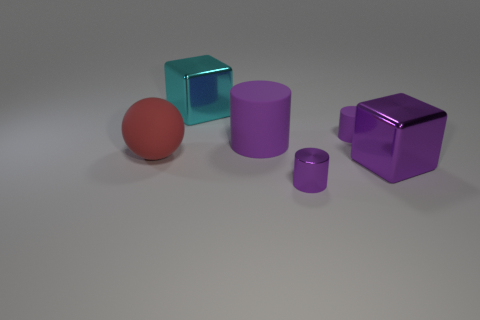What size is the block that is the same color as the small matte thing?
Offer a terse response. Large. How many blocks are the same size as the purple shiny cylinder?
Provide a short and direct response. 0. The object that is left of the small purple metallic cylinder and behind the big cylinder is what color?
Offer a terse response. Cyan. Are there fewer big matte cylinders than purple cylinders?
Make the answer very short. Yes. There is a shiny cylinder; does it have the same color as the large object in front of the big red matte thing?
Keep it short and to the point. Yes. Are there an equal number of red matte balls behind the big purple matte cylinder and small objects behind the purple block?
Offer a very short reply. No. What number of big red objects are the same shape as the tiny shiny thing?
Ensure brevity in your answer.  0. Are any tiny rubber objects visible?
Your answer should be very brief. Yes. Is the material of the large purple cylinder the same as the tiny purple cylinder that is behind the big red ball?
Keep it short and to the point. Yes. What is the material of the red sphere that is the same size as the purple metal cube?
Provide a succinct answer. Rubber. 